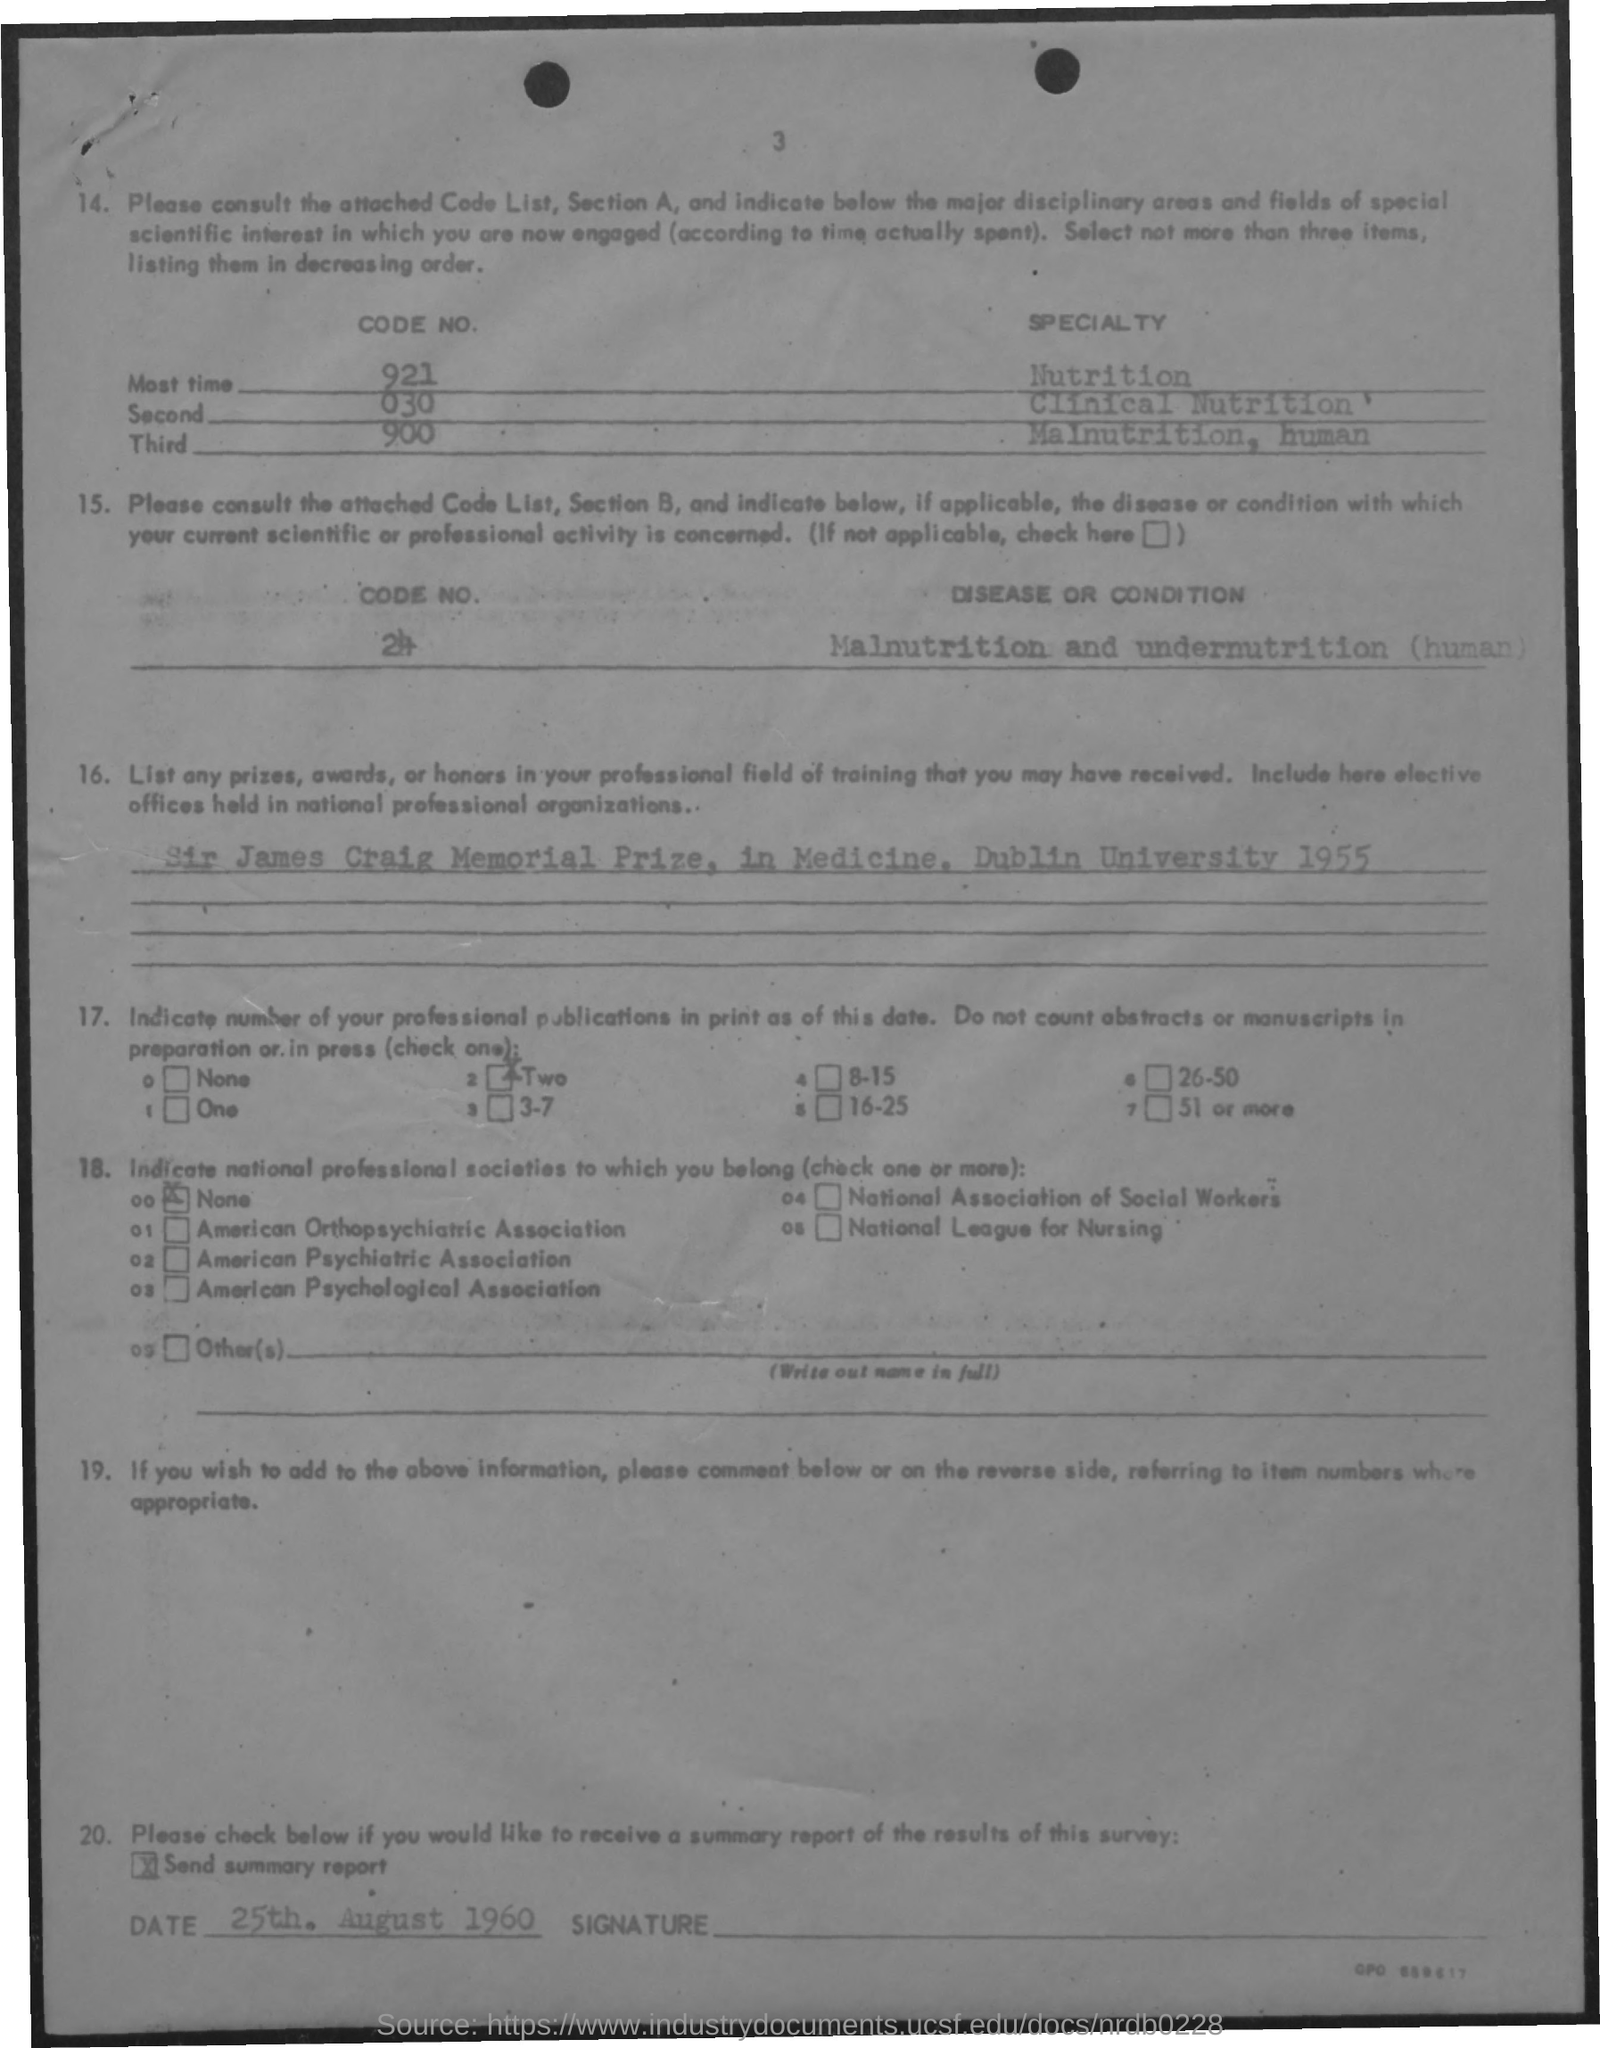Indicate a few pertinent items in this graphic. The specialty of code number 030 is Clinical Nutrition. The code number of 'Most time' is 921... The code number of "Third" is 900. The document contains a reference to the date of August 25, 1960. The page number is 3. 